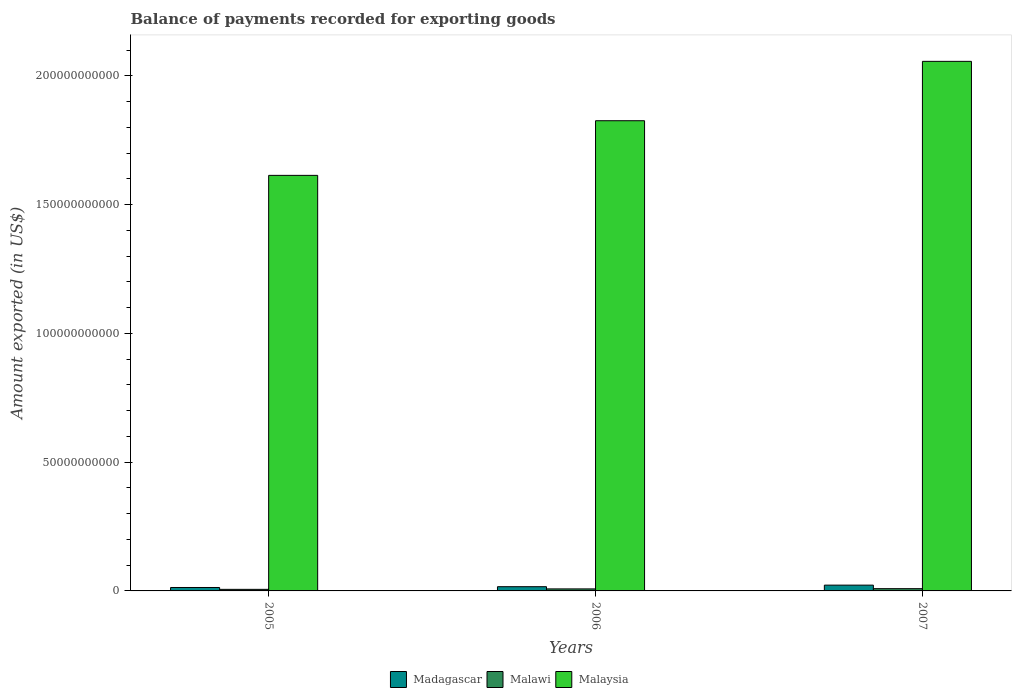Are the number of bars on each tick of the X-axis equal?
Make the answer very short. Yes. How many bars are there on the 1st tick from the left?
Provide a short and direct response. 3. How many bars are there on the 1st tick from the right?
Make the answer very short. 3. What is the label of the 2nd group of bars from the left?
Provide a succinct answer. 2006. In how many cases, is the number of bars for a given year not equal to the number of legend labels?
Your answer should be very brief. 0. What is the amount exported in Malawi in 2006?
Your answer should be very brief. 7.86e+08. Across all years, what is the maximum amount exported in Madagascar?
Give a very brief answer. 2.24e+09. Across all years, what is the minimum amount exported in Malawi?
Ensure brevity in your answer.  6.09e+08. In which year was the amount exported in Malaysia maximum?
Give a very brief answer. 2007. What is the total amount exported in Malaysia in the graph?
Give a very brief answer. 5.50e+11. What is the difference between the amount exported in Malawi in 2005 and that in 2007?
Provide a short and direct response. -2.69e+08. What is the difference between the amount exported in Malaysia in 2007 and the amount exported in Malawi in 2006?
Your response must be concise. 2.05e+11. What is the average amount exported in Madagascar per year?
Offer a terse response. 1.74e+09. In the year 2007, what is the difference between the amount exported in Malaysia and amount exported in Madagascar?
Your answer should be compact. 2.03e+11. What is the ratio of the amount exported in Madagascar in 2005 to that in 2006?
Keep it short and to the point. 0.81. Is the amount exported in Malaysia in 2005 less than that in 2007?
Your answer should be very brief. Yes. What is the difference between the highest and the second highest amount exported in Malaysia?
Keep it short and to the point. 2.31e+1. What is the difference between the highest and the lowest amount exported in Madagascar?
Your answer should be compact. 9.15e+08. In how many years, is the amount exported in Malawi greater than the average amount exported in Malawi taken over all years?
Provide a short and direct response. 2. What does the 3rd bar from the left in 2005 represents?
Ensure brevity in your answer.  Malaysia. What does the 2nd bar from the right in 2005 represents?
Provide a short and direct response. Malawi. Is it the case that in every year, the sum of the amount exported in Madagascar and amount exported in Malaysia is greater than the amount exported in Malawi?
Your answer should be compact. Yes. Are all the bars in the graph horizontal?
Make the answer very short. No. How many years are there in the graph?
Your response must be concise. 3. Does the graph contain any zero values?
Offer a very short reply. No. Where does the legend appear in the graph?
Ensure brevity in your answer.  Bottom center. How many legend labels are there?
Your answer should be very brief. 3. How are the legend labels stacked?
Offer a terse response. Horizontal. What is the title of the graph?
Provide a succinct answer. Balance of payments recorded for exporting goods. What is the label or title of the X-axis?
Ensure brevity in your answer.  Years. What is the label or title of the Y-axis?
Offer a very short reply. Amount exported (in US$). What is the Amount exported (in US$) of Madagascar in 2005?
Your answer should be very brief. 1.33e+09. What is the Amount exported (in US$) in Malawi in 2005?
Offer a very short reply. 6.09e+08. What is the Amount exported (in US$) in Malaysia in 2005?
Give a very brief answer. 1.61e+11. What is the Amount exported (in US$) in Madagascar in 2006?
Your response must be concise. 1.64e+09. What is the Amount exported (in US$) of Malawi in 2006?
Keep it short and to the point. 7.86e+08. What is the Amount exported (in US$) in Malaysia in 2006?
Your answer should be very brief. 1.83e+11. What is the Amount exported (in US$) of Madagascar in 2007?
Give a very brief answer. 2.24e+09. What is the Amount exported (in US$) in Malawi in 2007?
Keep it short and to the point. 8.77e+08. What is the Amount exported (in US$) in Malaysia in 2007?
Offer a terse response. 2.06e+11. Across all years, what is the maximum Amount exported (in US$) of Madagascar?
Offer a terse response. 2.24e+09. Across all years, what is the maximum Amount exported (in US$) of Malawi?
Offer a very short reply. 8.77e+08. Across all years, what is the maximum Amount exported (in US$) of Malaysia?
Make the answer very short. 2.06e+11. Across all years, what is the minimum Amount exported (in US$) in Madagascar?
Offer a very short reply. 1.33e+09. Across all years, what is the minimum Amount exported (in US$) of Malawi?
Keep it short and to the point. 6.09e+08. Across all years, what is the minimum Amount exported (in US$) of Malaysia?
Give a very brief answer. 1.61e+11. What is the total Amount exported (in US$) of Madagascar in the graph?
Keep it short and to the point. 5.21e+09. What is the total Amount exported (in US$) of Malawi in the graph?
Your response must be concise. 2.27e+09. What is the total Amount exported (in US$) in Malaysia in the graph?
Give a very brief answer. 5.50e+11. What is the difference between the Amount exported (in US$) in Madagascar in 2005 and that in 2006?
Your response must be concise. -3.09e+08. What is the difference between the Amount exported (in US$) of Malawi in 2005 and that in 2006?
Offer a terse response. -1.77e+08. What is the difference between the Amount exported (in US$) of Malaysia in 2005 and that in 2006?
Ensure brevity in your answer.  -2.12e+1. What is the difference between the Amount exported (in US$) of Madagascar in 2005 and that in 2007?
Ensure brevity in your answer.  -9.15e+08. What is the difference between the Amount exported (in US$) of Malawi in 2005 and that in 2007?
Your answer should be very brief. -2.69e+08. What is the difference between the Amount exported (in US$) of Malaysia in 2005 and that in 2007?
Your answer should be compact. -4.43e+1. What is the difference between the Amount exported (in US$) of Madagascar in 2006 and that in 2007?
Keep it short and to the point. -6.06e+08. What is the difference between the Amount exported (in US$) in Malawi in 2006 and that in 2007?
Provide a succinct answer. -9.17e+07. What is the difference between the Amount exported (in US$) of Malaysia in 2006 and that in 2007?
Ensure brevity in your answer.  -2.31e+1. What is the difference between the Amount exported (in US$) of Madagascar in 2005 and the Amount exported (in US$) of Malawi in 2006?
Ensure brevity in your answer.  5.44e+08. What is the difference between the Amount exported (in US$) of Madagascar in 2005 and the Amount exported (in US$) of Malaysia in 2006?
Provide a succinct answer. -1.81e+11. What is the difference between the Amount exported (in US$) of Malawi in 2005 and the Amount exported (in US$) of Malaysia in 2006?
Ensure brevity in your answer.  -1.82e+11. What is the difference between the Amount exported (in US$) of Madagascar in 2005 and the Amount exported (in US$) of Malawi in 2007?
Offer a very short reply. 4.52e+08. What is the difference between the Amount exported (in US$) in Madagascar in 2005 and the Amount exported (in US$) in Malaysia in 2007?
Provide a short and direct response. -2.04e+11. What is the difference between the Amount exported (in US$) of Malawi in 2005 and the Amount exported (in US$) of Malaysia in 2007?
Ensure brevity in your answer.  -2.05e+11. What is the difference between the Amount exported (in US$) of Madagascar in 2006 and the Amount exported (in US$) of Malawi in 2007?
Give a very brief answer. 7.61e+08. What is the difference between the Amount exported (in US$) of Madagascar in 2006 and the Amount exported (in US$) of Malaysia in 2007?
Ensure brevity in your answer.  -2.04e+11. What is the difference between the Amount exported (in US$) in Malawi in 2006 and the Amount exported (in US$) in Malaysia in 2007?
Your answer should be very brief. -2.05e+11. What is the average Amount exported (in US$) in Madagascar per year?
Your answer should be compact. 1.74e+09. What is the average Amount exported (in US$) in Malawi per year?
Offer a very short reply. 7.57e+08. What is the average Amount exported (in US$) in Malaysia per year?
Keep it short and to the point. 1.83e+11. In the year 2005, what is the difference between the Amount exported (in US$) of Madagascar and Amount exported (in US$) of Malawi?
Offer a very short reply. 7.21e+08. In the year 2005, what is the difference between the Amount exported (in US$) of Madagascar and Amount exported (in US$) of Malaysia?
Provide a succinct answer. -1.60e+11. In the year 2005, what is the difference between the Amount exported (in US$) of Malawi and Amount exported (in US$) of Malaysia?
Make the answer very short. -1.61e+11. In the year 2006, what is the difference between the Amount exported (in US$) in Madagascar and Amount exported (in US$) in Malawi?
Ensure brevity in your answer.  8.53e+08. In the year 2006, what is the difference between the Amount exported (in US$) in Madagascar and Amount exported (in US$) in Malaysia?
Ensure brevity in your answer.  -1.81e+11. In the year 2006, what is the difference between the Amount exported (in US$) of Malawi and Amount exported (in US$) of Malaysia?
Your answer should be very brief. -1.82e+11. In the year 2007, what is the difference between the Amount exported (in US$) of Madagascar and Amount exported (in US$) of Malawi?
Provide a succinct answer. 1.37e+09. In the year 2007, what is the difference between the Amount exported (in US$) of Madagascar and Amount exported (in US$) of Malaysia?
Your response must be concise. -2.03e+11. In the year 2007, what is the difference between the Amount exported (in US$) of Malawi and Amount exported (in US$) of Malaysia?
Offer a terse response. -2.05e+11. What is the ratio of the Amount exported (in US$) of Madagascar in 2005 to that in 2006?
Keep it short and to the point. 0.81. What is the ratio of the Amount exported (in US$) of Malawi in 2005 to that in 2006?
Keep it short and to the point. 0.77. What is the ratio of the Amount exported (in US$) in Malaysia in 2005 to that in 2006?
Give a very brief answer. 0.88. What is the ratio of the Amount exported (in US$) of Madagascar in 2005 to that in 2007?
Provide a short and direct response. 0.59. What is the ratio of the Amount exported (in US$) of Malawi in 2005 to that in 2007?
Provide a short and direct response. 0.69. What is the ratio of the Amount exported (in US$) in Malaysia in 2005 to that in 2007?
Provide a succinct answer. 0.78. What is the ratio of the Amount exported (in US$) in Madagascar in 2006 to that in 2007?
Offer a very short reply. 0.73. What is the ratio of the Amount exported (in US$) in Malawi in 2006 to that in 2007?
Keep it short and to the point. 0.9. What is the ratio of the Amount exported (in US$) in Malaysia in 2006 to that in 2007?
Give a very brief answer. 0.89. What is the difference between the highest and the second highest Amount exported (in US$) in Madagascar?
Give a very brief answer. 6.06e+08. What is the difference between the highest and the second highest Amount exported (in US$) of Malawi?
Offer a very short reply. 9.17e+07. What is the difference between the highest and the second highest Amount exported (in US$) in Malaysia?
Offer a terse response. 2.31e+1. What is the difference between the highest and the lowest Amount exported (in US$) in Madagascar?
Your response must be concise. 9.15e+08. What is the difference between the highest and the lowest Amount exported (in US$) in Malawi?
Keep it short and to the point. 2.69e+08. What is the difference between the highest and the lowest Amount exported (in US$) of Malaysia?
Keep it short and to the point. 4.43e+1. 